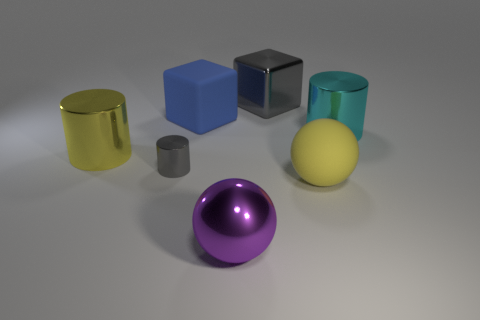Add 3 small cyan metal cubes. How many objects exist? 10 Subtract all cubes. How many objects are left? 5 Subtract 0 green cylinders. How many objects are left? 7 Subtract all small yellow cubes. Subtract all tiny gray objects. How many objects are left? 6 Add 5 gray things. How many gray things are left? 7 Add 5 small cyan metal balls. How many small cyan metal balls exist? 5 